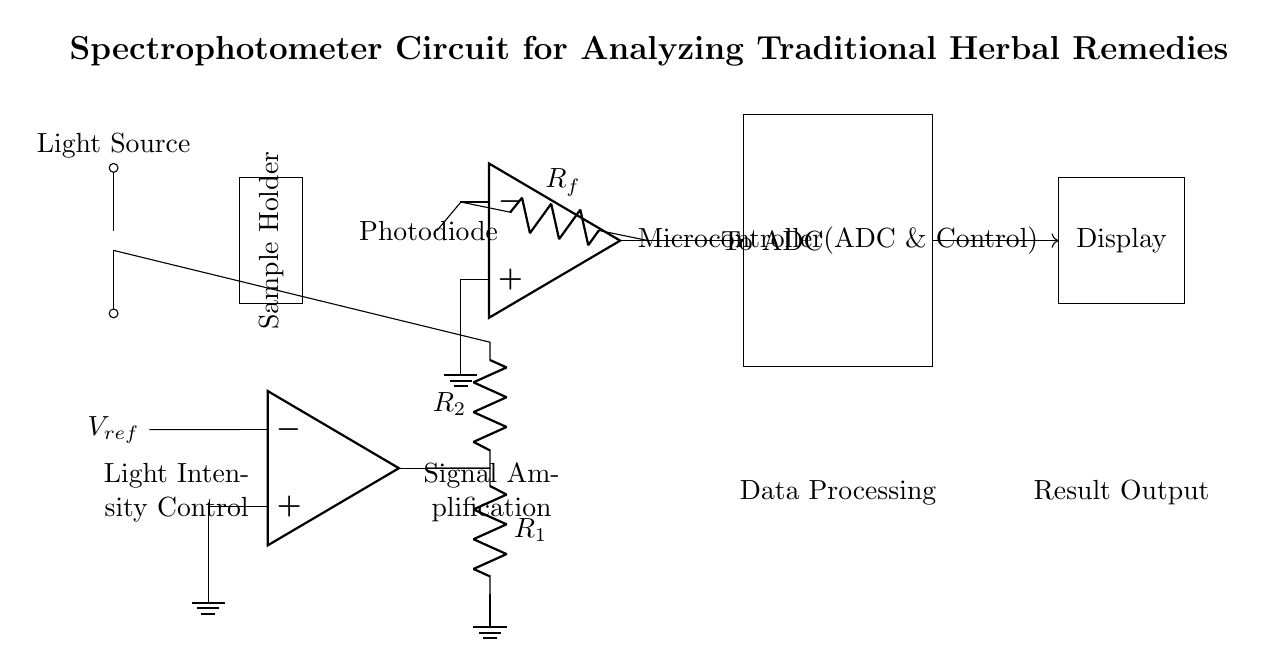What is the light source in this circuit? The light source is represented by the lamp symbol, identified at the beginning of the circuit diagram.
Answer: Lamp What type of amplifier is used in this circuit? The circuit uses a transimpedance amplifier, indicated by the operational amplifier symbol connected to the photodiode.
Answer: Transimpedance What component is connected to the output of the transimpedance amplifier? The output of the transimpedance amplifier is connected to an analog-to-digital converter (ADC), indicated in the diagram.
Answer: To ADC What is the purpose of the sample holder in this circuit? The sample holder serves to contain the herbal remedy being analyzed, providing a space for light to pass through during measurement.
Answer: Analyze samples What is the primary function of the microcontroller in the circuit? The microcontroller processes the signals from the ADC and controls the overall operation of the spectrophotometer.
Answer: Data processing How are the reference voltage and the light source connected? The reference voltage is connected to an operational amplifier which also connects to the light source through resistors in parallel, allowing for control of light intensity.
Answer: Through resistors What is the output from the microcontroller? The output from the microcontroller is sent to the display, where results of the analysis are shown.
Answer: Results output 